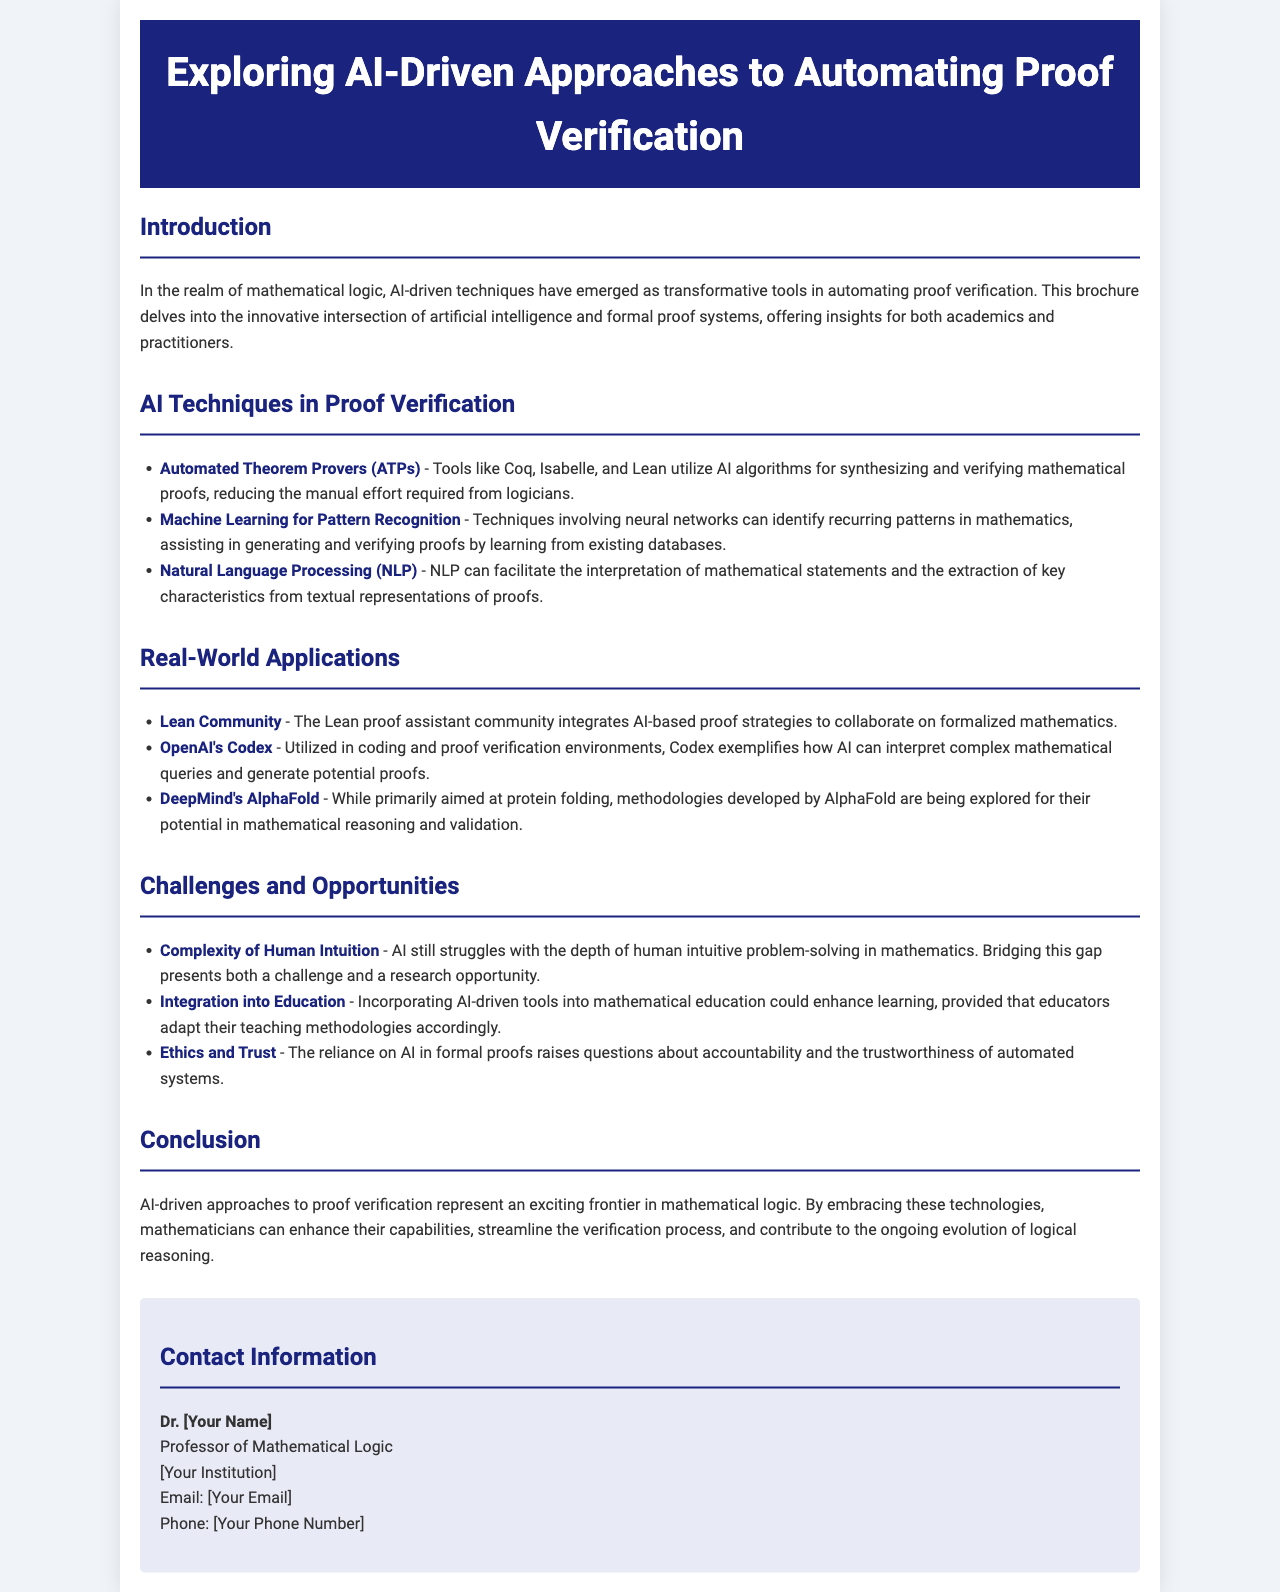What is the title of the brochure? The title is found in the header section of the document, which states "Exploring AI-Driven Approaches to Automating Proof Verification."
Answer: Exploring AI-Driven Approaches to Automating Proof Verification Which AI technique is utilized by Coq, Isabelle, and Lean? The document mentions that these tools employ "Automated Theorem Provers (ATPs)" for synthesizing and verifying mathematical proofs.
Answer: Automated Theorem Provers (ATPs) What opportunity does AI integration in education present? The document states that incorporating AI-driven tools could enhance learning, which suggests a significant opportunity for improvement in educational methodologies.
Answer: Enhance learning Who is part of the Lean proof assistant community? The document refers to the "Lean Community" as a group that integrates AI-based proof strategies, indicating their involvement in formalized mathematics.
Answer: Lean Community What challenge does AI face in mathematical reasoning? The document highlights the "Complexity of Human Intuition" as a significant challenge that AI struggles to match in the realm of problem-solving.
Answer: Complexity of Human Intuition What is one real-world application of OpenAI's Codex? The document mentions that Codex is "utilized in coding and proof verification environments," illustrating its practical usage in real-world scenarios.
Answer: Coding and proof verification environments What is a significant ethical concern raised by reliance on AI? The document discusses "Ethics and Trust" as an important topic regarding accountability and the trustworthiness of automated systems in formal proofs.
Answer: Ethics and Trust What is the document type? The structure and content suggest that this is an informational brochure aimed at providing insights into AI-driven techniques in proof verification.
Answer: Informational brochure 